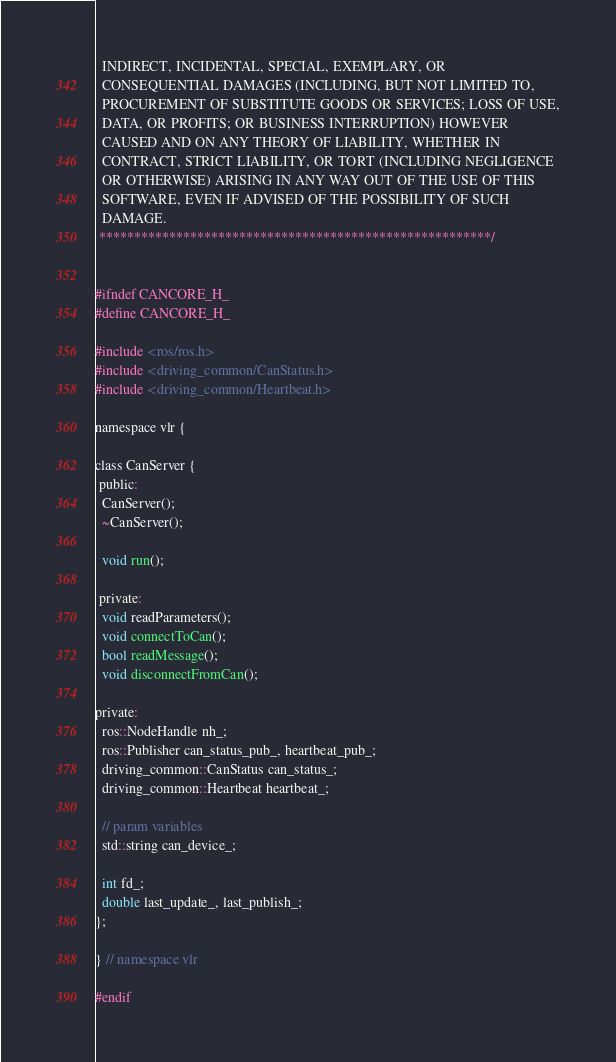Convert code to text. <code><loc_0><loc_0><loc_500><loc_500><_C_>  INDIRECT, INCIDENTAL, SPECIAL, EXEMPLARY, OR 
  CONSEQUENTIAL DAMAGES (INCLUDING, BUT NOT LIMITED TO, 
  PROCUREMENT OF SUBSTITUTE GOODS OR SERVICES; LOSS OF USE,
  DATA, OR PROFITS; OR BUSINESS INTERRUPTION) HOWEVER
  CAUSED AND ON ANY THEORY OF LIABILITY, WHETHER IN 
  CONTRACT, STRICT LIABILITY, OR TORT (INCLUDING NEGLIGENCE 
  OR OTHERWISE) ARISING IN ANY WAY OUT OF THE USE OF THIS
  SOFTWARE, EVEN IF ADVISED OF THE POSSIBILITY OF SUCH
  DAMAGE.
 ********************************************************/


#ifndef CANCORE_H_
#define CANCORE_H_

#include <ros/ros.h>
#include <driving_common/CanStatus.h>
#include <driving_common/Heartbeat.h>

namespace vlr {

class CanServer {
 public:
  CanServer();
  ~CanServer();

  void run();

 private:
  void readParameters();
  void connectToCan();
  bool readMessage();
  void disconnectFromCan();

private:
  ros::NodeHandle nh_;
  ros::Publisher can_status_pub_, heartbeat_pub_;
  driving_common::CanStatus can_status_;
  driving_common::Heartbeat heartbeat_;

  // param variables
  std::string can_device_;

  int fd_;
  double last_update_, last_publish_;
};

} // namespace vlr

#endif
</code> 